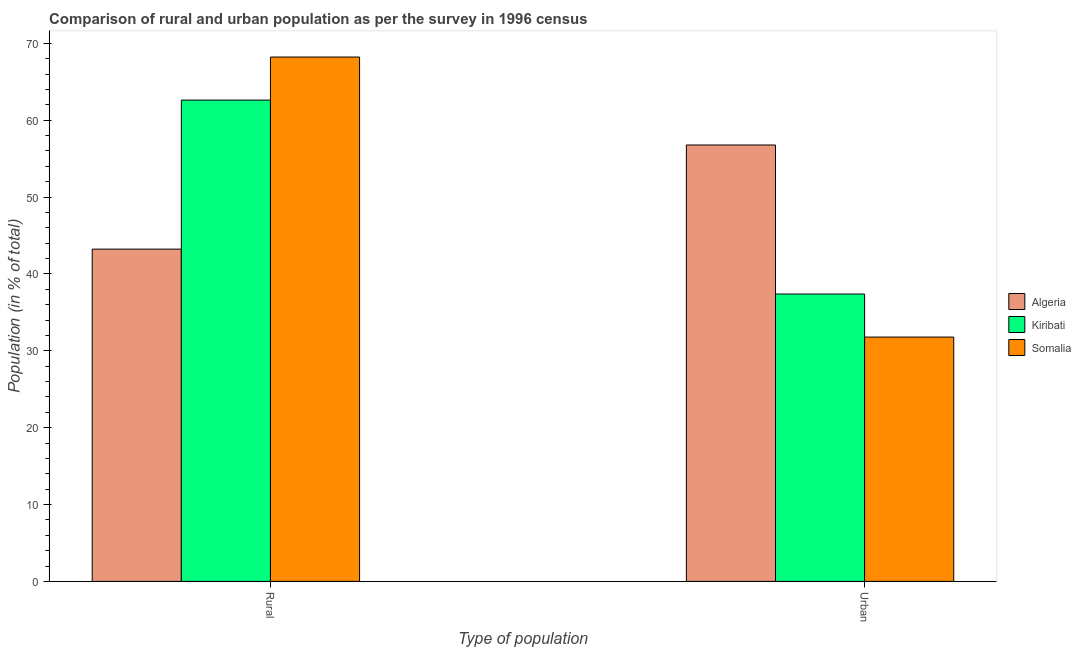How many different coloured bars are there?
Provide a succinct answer. 3. Are the number of bars per tick equal to the number of legend labels?
Offer a terse response. Yes. Are the number of bars on each tick of the X-axis equal?
Your response must be concise. Yes. How many bars are there on the 2nd tick from the left?
Your answer should be very brief. 3. What is the label of the 2nd group of bars from the left?
Offer a very short reply. Urban. What is the rural population in Somalia?
Keep it short and to the point. 68.22. Across all countries, what is the maximum urban population?
Offer a very short reply. 56.77. Across all countries, what is the minimum urban population?
Keep it short and to the point. 31.79. In which country was the urban population maximum?
Your answer should be compact. Algeria. In which country was the rural population minimum?
Provide a succinct answer. Algeria. What is the total rural population in the graph?
Keep it short and to the point. 174.06. What is the difference between the rural population in Algeria and that in Kiribati?
Ensure brevity in your answer.  -19.39. What is the difference between the rural population in Algeria and the urban population in Somalia?
Provide a succinct answer. 11.44. What is the average urban population per country?
Your response must be concise. 41.98. What is the difference between the rural population and urban population in Kiribati?
Provide a short and direct response. 25.23. What is the ratio of the rural population in Kiribati to that in Somalia?
Your answer should be compact. 0.92. Is the rural population in Algeria less than that in Somalia?
Ensure brevity in your answer.  Yes. What does the 3rd bar from the left in Rural represents?
Make the answer very short. Somalia. What does the 1st bar from the right in Urban represents?
Your response must be concise. Somalia. What is the difference between two consecutive major ticks on the Y-axis?
Give a very brief answer. 10. Does the graph contain any zero values?
Provide a short and direct response. No. Where does the legend appear in the graph?
Make the answer very short. Center right. How many legend labels are there?
Provide a succinct answer. 3. What is the title of the graph?
Your response must be concise. Comparison of rural and urban population as per the survey in 1996 census. Does "Ireland" appear as one of the legend labels in the graph?
Make the answer very short. No. What is the label or title of the X-axis?
Your answer should be very brief. Type of population. What is the label or title of the Y-axis?
Give a very brief answer. Population (in % of total). What is the Population (in % of total) in Algeria in Rural?
Keep it short and to the point. 43.23. What is the Population (in % of total) of Kiribati in Rural?
Keep it short and to the point. 62.61. What is the Population (in % of total) in Somalia in Rural?
Provide a succinct answer. 68.22. What is the Population (in % of total) in Algeria in Urban?
Make the answer very short. 56.77. What is the Population (in % of total) of Kiribati in Urban?
Your response must be concise. 37.39. What is the Population (in % of total) in Somalia in Urban?
Your answer should be compact. 31.79. Across all Type of population, what is the maximum Population (in % of total) of Algeria?
Keep it short and to the point. 56.77. Across all Type of population, what is the maximum Population (in % of total) in Kiribati?
Keep it short and to the point. 62.61. Across all Type of population, what is the maximum Population (in % of total) in Somalia?
Make the answer very short. 68.22. Across all Type of population, what is the minimum Population (in % of total) in Algeria?
Your answer should be very brief. 43.23. Across all Type of population, what is the minimum Population (in % of total) in Kiribati?
Make the answer very short. 37.39. Across all Type of population, what is the minimum Population (in % of total) of Somalia?
Offer a very short reply. 31.79. What is the total Population (in % of total) in Algeria in the graph?
Give a very brief answer. 100. What is the total Population (in % of total) of Kiribati in the graph?
Keep it short and to the point. 100. What is the total Population (in % of total) in Somalia in the graph?
Offer a terse response. 100. What is the difference between the Population (in % of total) of Algeria in Rural and that in Urban?
Provide a short and direct response. -13.55. What is the difference between the Population (in % of total) of Kiribati in Rural and that in Urban?
Your answer should be very brief. 25.23. What is the difference between the Population (in % of total) in Somalia in Rural and that in Urban?
Provide a succinct answer. 36.43. What is the difference between the Population (in % of total) of Algeria in Rural and the Population (in % of total) of Kiribati in Urban?
Make the answer very short. 5.84. What is the difference between the Population (in % of total) of Algeria in Rural and the Population (in % of total) of Somalia in Urban?
Your answer should be very brief. 11.44. What is the difference between the Population (in % of total) of Kiribati in Rural and the Population (in % of total) of Somalia in Urban?
Provide a succinct answer. 30.83. What is the average Population (in % of total) of Algeria per Type of population?
Keep it short and to the point. 50. What is the average Population (in % of total) of Somalia per Type of population?
Offer a very short reply. 50. What is the difference between the Population (in % of total) of Algeria and Population (in % of total) of Kiribati in Rural?
Give a very brief answer. -19.39. What is the difference between the Population (in % of total) in Algeria and Population (in % of total) in Somalia in Rural?
Make the answer very short. -24.99. What is the difference between the Population (in % of total) of Kiribati and Population (in % of total) of Somalia in Rural?
Offer a very short reply. -5.6. What is the difference between the Population (in % of total) of Algeria and Population (in % of total) of Kiribati in Urban?
Your answer should be compact. 19.39. What is the difference between the Population (in % of total) of Algeria and Population (in % of total) of Somalia in Urban?
Your answer should be compact. 24.99. What is the difference between the Population (in % of total) of Kiribati and Population (in % of total) of Somalia in Urban?
Keep it short and to the point. 5.6. What is the ratio of the Population (in % of total) in Algeria in Rural to that in Urban?
Ensure brevity in your answer.  0.76. What is the ratio of the Population (in % of total) in Kiribati in Rural to that in Urban?
Your response must be concise. 1.67. What is the ratio of the Population (in % of total) in Somalia in Rural to that in Urban?
Ensure brevity in your answer.  2.15. What is the difference between the highest and the second highest Population (in % of total) of Algeria?
Provide a short and direct response. 13.55. What is the difference between the highest and the second highest Population (in % of total) in Kiribati?
Offer a very short reply. 25.23. What is the difference between the highest and the second highest Population (in % of total) in Somalia?
Offer a terse response. 36.43. What is the difference between the highest and the lowest Population (in % of total) in Algeria?
Keep it short and to the point. 13.55. What is the difference between the highest and the lowest Population (in % of total) in Kiribati?
Give a very brief answer. 25.23. What is the difference between the highest and the lowest Population (in % of total) of Somalia?
Keep it short and to the point. 36.43. 